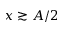<formula> <loc_0><loc_0><loc_500><loc_500>x \gtrsim A / 2</formula> 